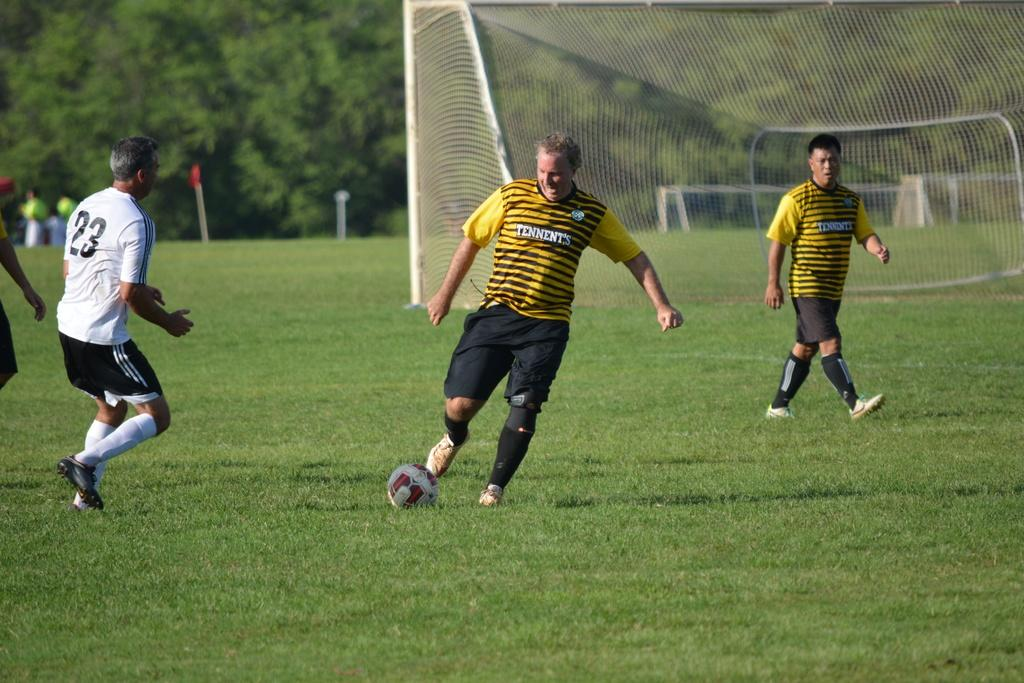How many people are playing football in the image? There are four people in the image. What are the people doing in the image? The people are playing football. What is the color of the football field? The football field is green. What is present near the field to catch the ball? There is a net in the image. What can be seen in the background of the image? There are trees around the field. What is the error rate of the men in the image? There are no men mentioned in the image, and there is no indication of an error rate. 